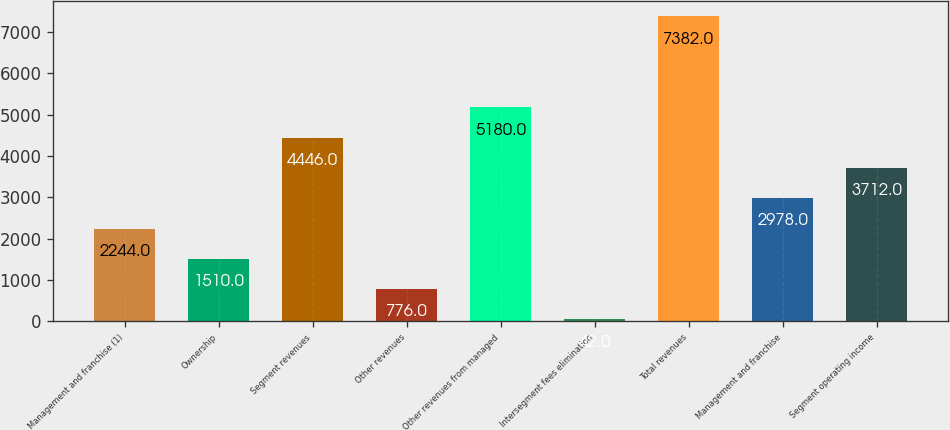Convert chart. <chart><loc_0><loc_0><loc_500><loc_500><bar_chart><fcel>Management and franchise (1)<fcel>Ownership<fcel>Segment revenues<fcel>Other revenues<fcel>Other revenues from managed<fcel>Intersegment fees elimination<fcel>Total revenues<fcel>Management and franchise<fcel>Segment operating income<nl><fcel>2244<fcel>1510<fcel>4446<fcel>776<fcel>5180<fcel>42<fcel>7382<fcel>2978<fcel>3712<nl></chart> 